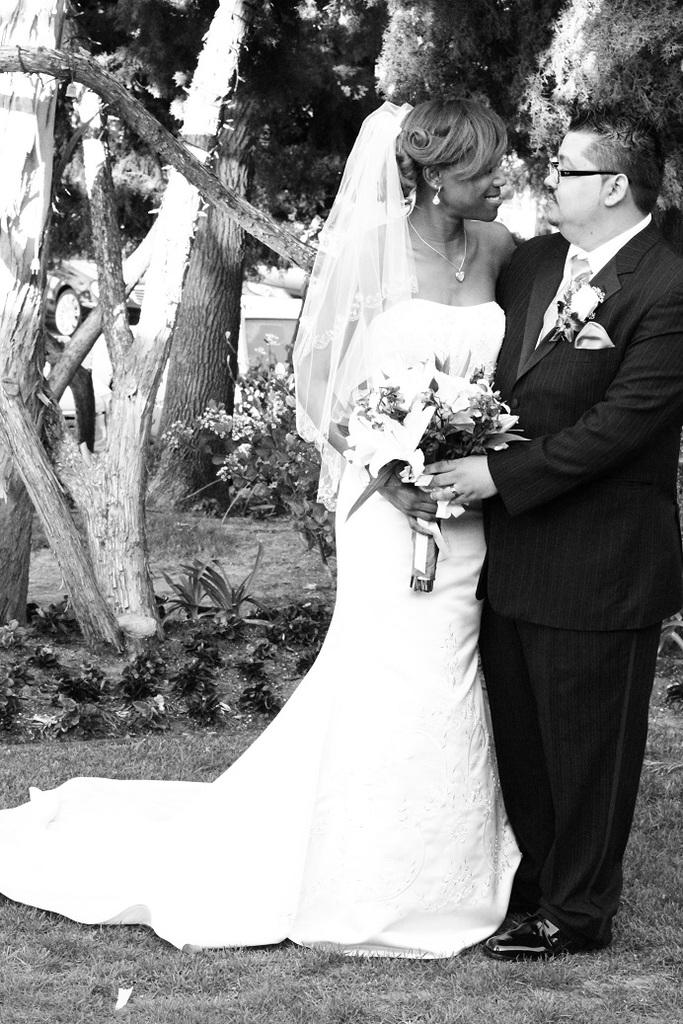What is the color scheme of the image? The image is black and white. How many people are in the image? There are two persons in the image. Where are the persons standing? The persons are standing on the grass. What are the persons holding? The persons are holding a flower bouquet. What can be seen in the background of the image? There are trees and plants in the background of the image. Is there a beggar asking for money in the image? There is no beggar present in the image. What type of building can be seen in the background of the image? There are no buildings visible in the background of the image; only trees and plants can be seen. 